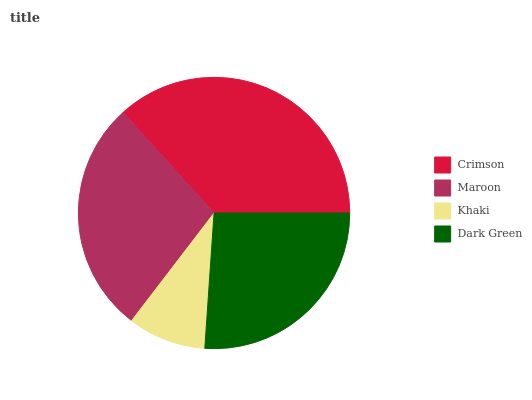Is Khaki the minimum?
Answer yes or no. Yes. Is Crimson the maximum?
Answer yes or no. Yes. Is Maroon the minimum?
Answer yes or no. No. Is Maroon the maximum?
Answer yes or no. No. Is Crimson greater than Maroon?
Answer yes or no. Yes. Is Maroon less than Crimson?
Answer yes or no. Yes. Is Maroon greater than Crimson?
Answer yes or no. No. Is Crimson less than Maroon?
Answer yes or no. No. Is Maroon the high median?
Answer yes or no. Yes. Is Dark Green the low median?
Answer yes or no. Yes. Is Crimson the high median?
Answer yes or no. No. Is Maroon the low median?
Answer yes or no. No. 